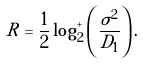Convert formula to latex. <formula><loc_0><loc_0><loc_500><loc_500>R = \frac { 1 } { 2 } \log _ { 2 } ^ { + } \left ( \frac { \sigma ^ { 2 } } { D _ { 1 } } \right ) .</formula> 